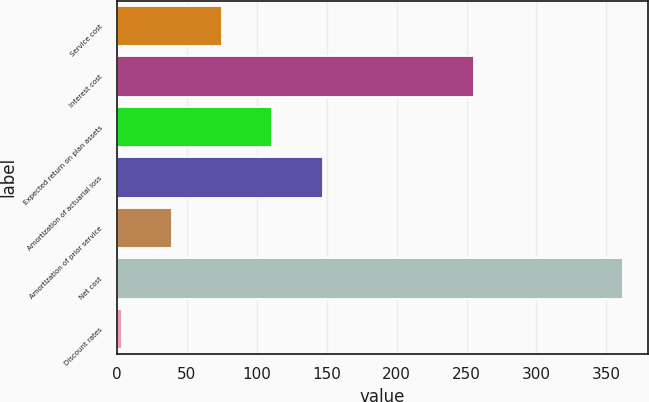<chart> <loc_0><loc_0><loc_500><loc_500><bar_chart><fcel>Service cost<fcel>Interest cost<fcel>Expected return on plan assets<fcel>Amortization of actuarial loss<fcel>Amortization of prior service<fcel>Net cost<fcel>Discount rates<nl><fcel>75.44<fcel>255<fcel>111.26<fcel>147.08<fcel>39.62<fcel>362<fcel>3.8<nl></chart> 